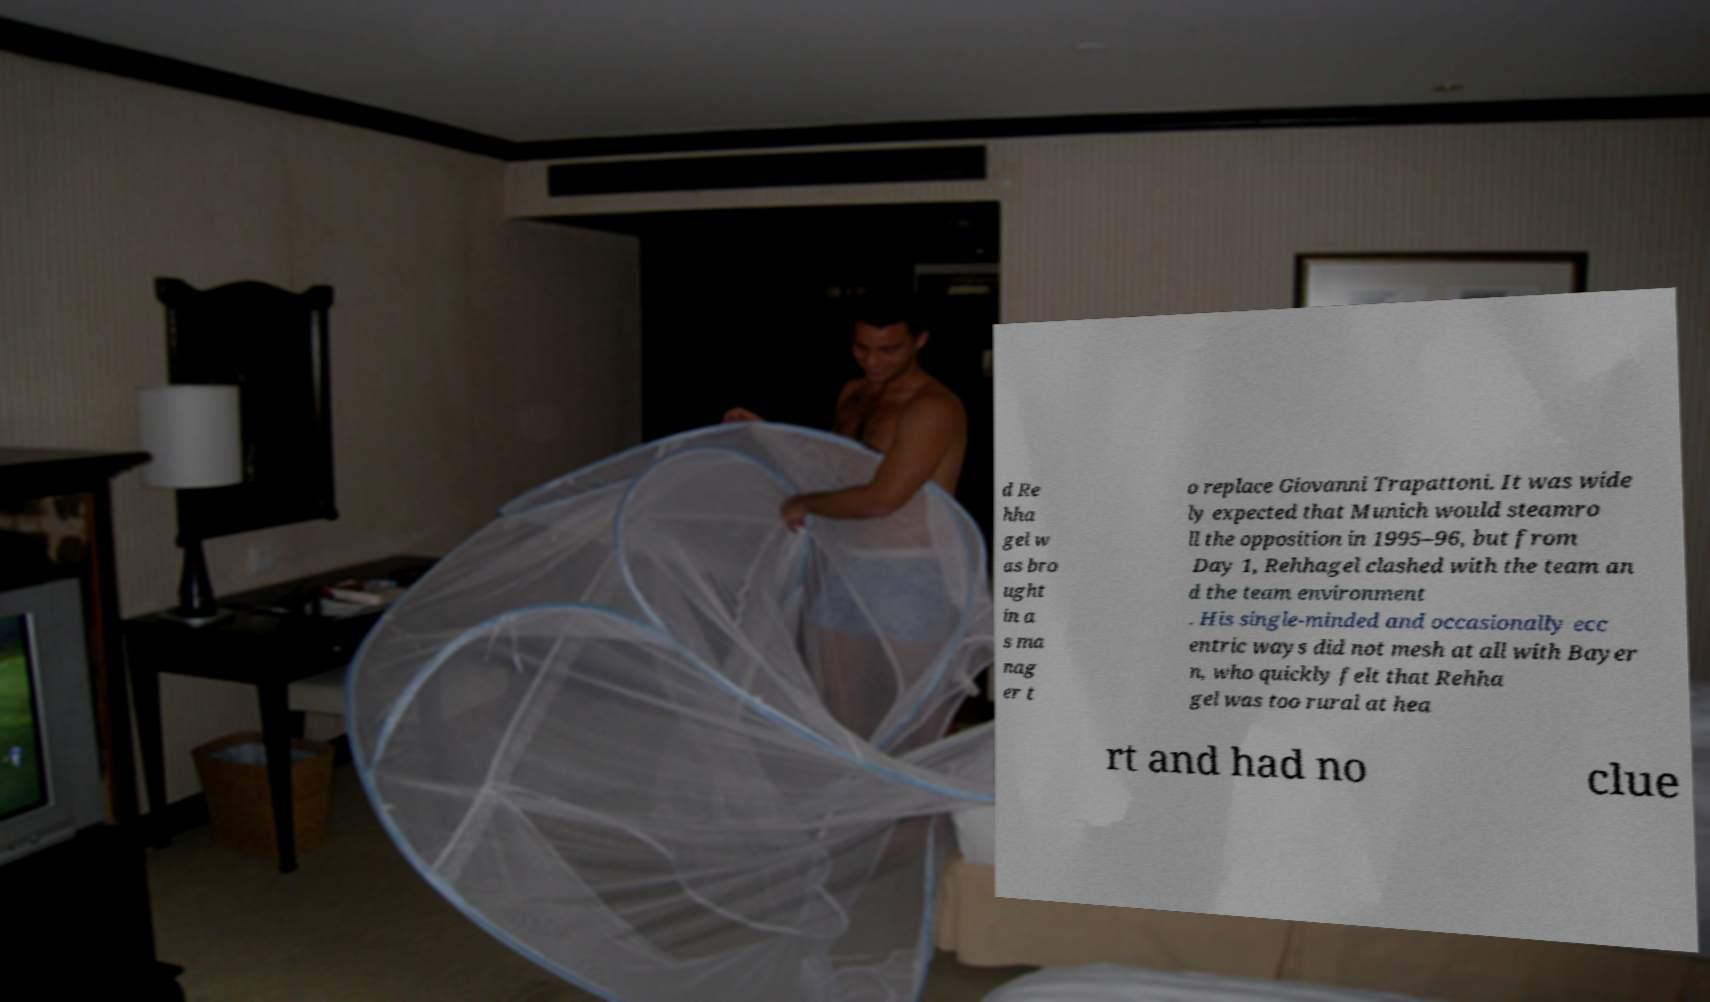For documentation purposes, I need the text within this image transcribed. Could you provide that? d Re hha gel w as bro ught in a s ma nag er t o replace Giovanni Trapattoni. It was wide ly expected that Munich would steamro ll the opposition in 1995–96, but from Day 1, Rehhagel clashed with the team an d the team environment . His single-minded and occasionally ecc entric ways did not mesh at all with Bayer n, who quickly felt that Rehha gel was too rural at hea rt and had no clue 